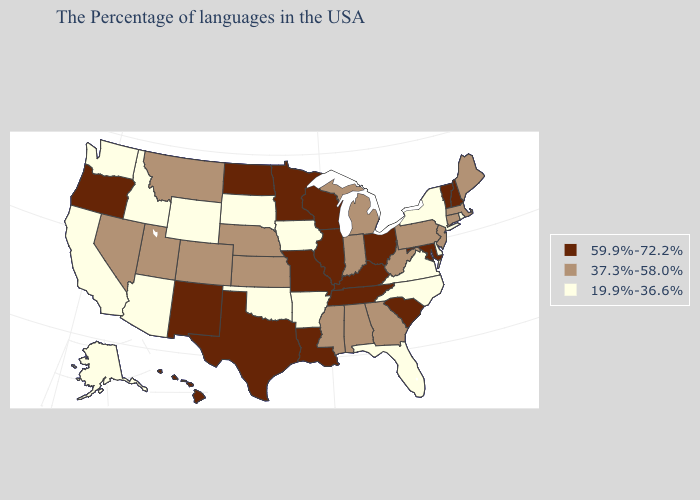Which states have the lowest value in the West?
Write a very short answer. Wyoming, Arizona, Idaho, California, Washington, Alaska. Does Delaware have the highest value in the USA?
Short answer required. No. Name the states that have a value in the range 19.9%-36.6%?
Concise answer only. Rhode Island, New York, Delaware, Virginia, North Carolina, Florida, Arkansas, Iowa, Oklahoma, South Dakota, Wyoming, Arizona, Idaho, California, Washington, Alaska. Which states have the lowest value in the South?
Keep it brief. Delaware, Virginia, North Carolina, Florida, Arkansas, Oklahoma. Does Idaho have the same value as Virginia?
Short answer required. Yes. Name the states that have a value in the range 19.9%-36.6%?
Give a very brief answer. Rhode Island, New York, Delaware, Virginia, North Carolina, Florida, Arkansas, Iowa, Oklahoma, South Dakota, Wyoming, Arizona, Idaho, California, Washington, Alaska. Does Vermont have the highest value in the USA?
Keep it brief. Yes. Among the states that border Wisconsin , which have the highest value?
Keep it brief. Illinois, Minnesota. Among the states that border Maryland , does Pennsylvania have the lowest value?
Quick response, please. No. Name the states that have a value in the range 37.3%-58.0%?
Answer briefly. Maine, Massachusetts, Connecticut, New Jersey, Pennsylvania, West Virginia, Georgia, Michigan, Indiana, Alabama, Mississippi, Kansas, Nebraska, Colorado, Utah, Montana, Nevada. Name the states that have a value in the range 59.9%-72.2%?
Be succinct. New Hampshire, Vermont, Maryland, South Carolina, Ohio, Kentucky, Tennessee, Wisconsin, Illinois, Louisiana, Missouri, Minnesota, Texas, North Dakota, New Mexico, Oregon, Hawaii. What is the highest value in the USA?
Give a very brief answer. 59.9%-72.2%. What is the value of California?
Write a very short answer. 19.9%-36.6%. What is the value of Oklahoma?
Concise answer only. 19.9%-36.6%. Among the states that border Alabama , does Tennessee have the highest value?
Give a very brief answer. Yes. 